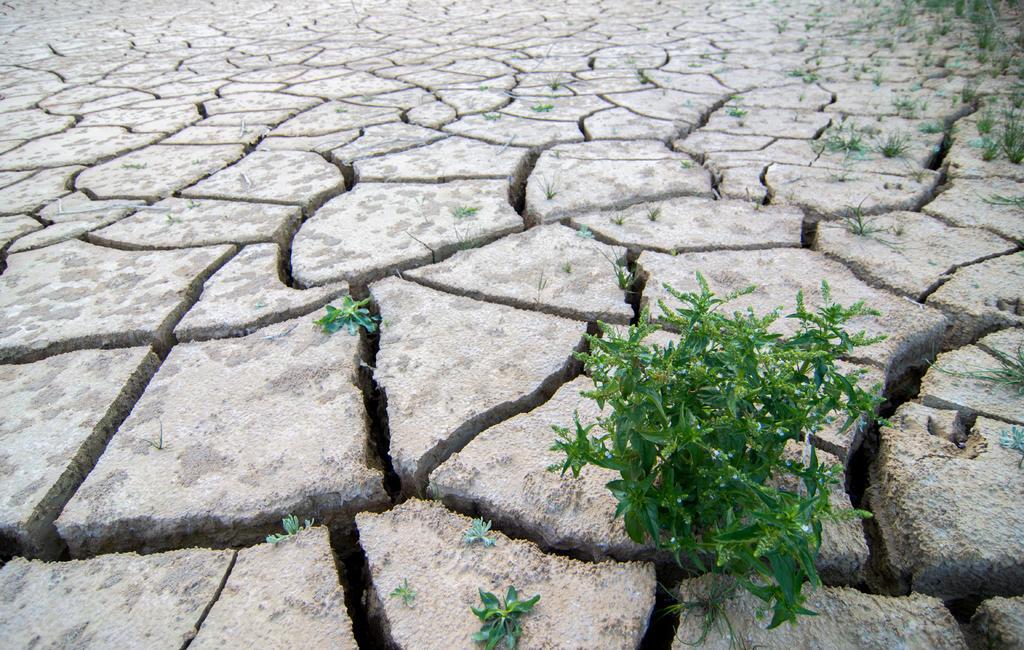Please provide a concise description of this image. In this image I can see the ground, few cracks on the ground, few plants which are green in color and some grass. 